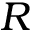Convert formula to latex. <formula><loc_0><loc_0><loc_500><loc_500>R</formula> 